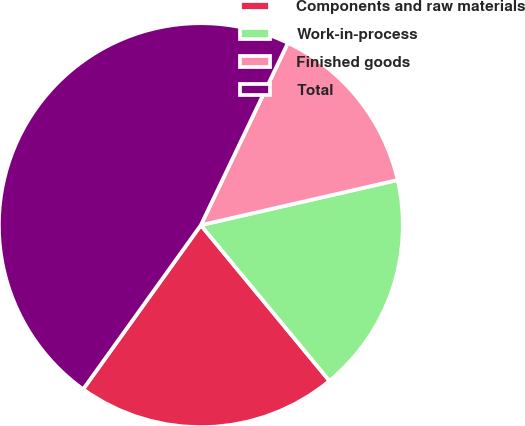Convert chart to OTSL. <chart><loc_0><loc_0><loc_500><loc_500><pie_chart><fcel>Components and raw materials<fcel>Work-in-process<fcel>Finished goods<fcel>Total<nl><fcel>20.89%<fcel>17.6%<fcel>14.32%<fcel>47.19%<nl></chart> 